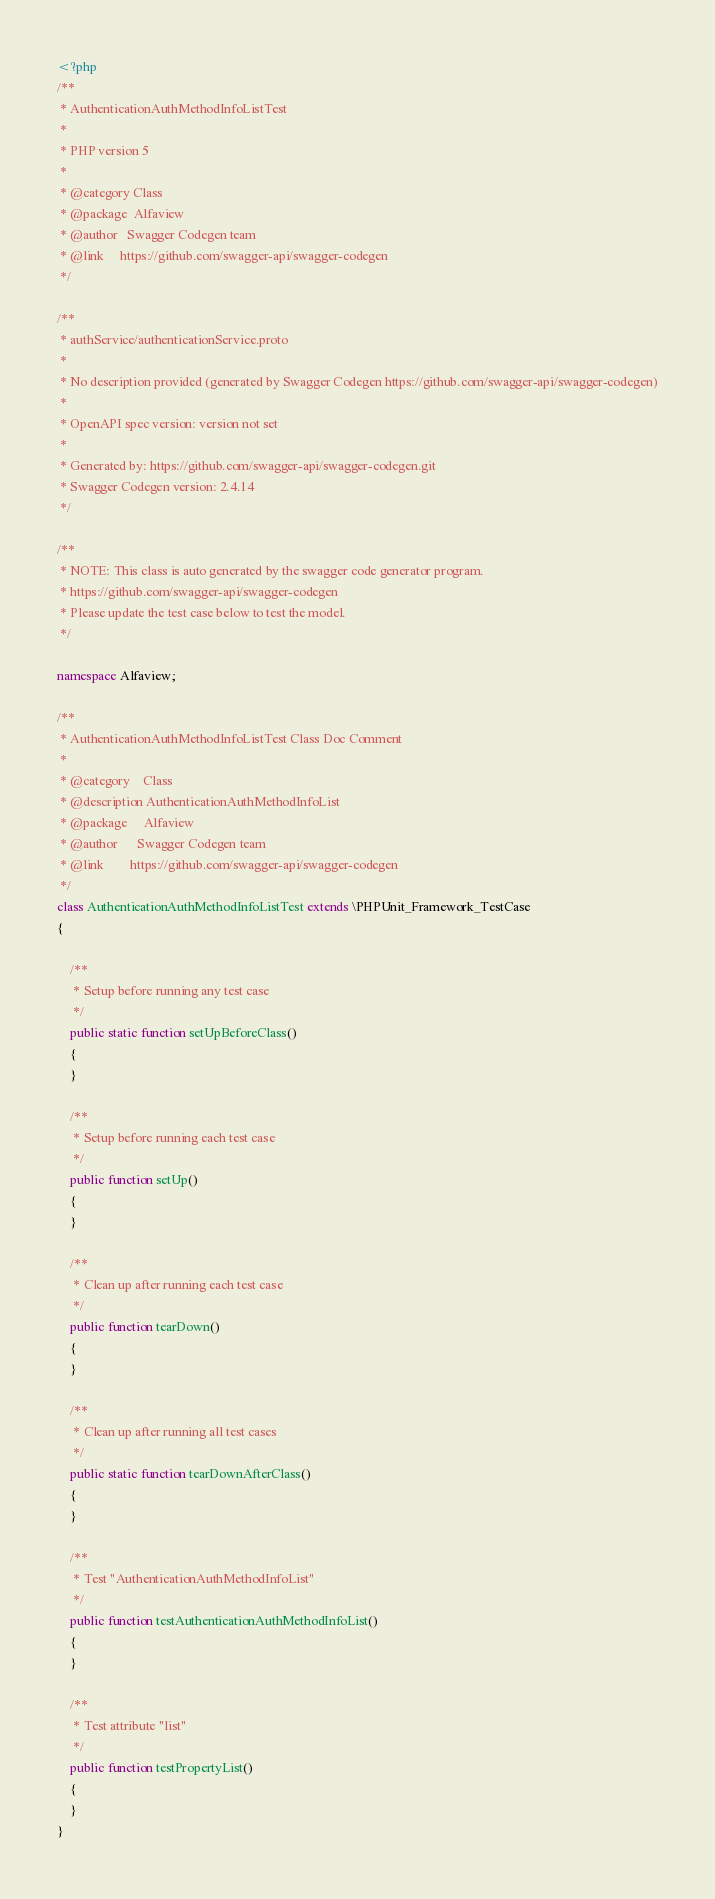Convert code to text. <code><loc_0><loc_0><loc_500><loc_500><_PHP_><?php
/**
 * AuthenticationAuthMethodInfoListTest
 *
 * PHP version 5
 *
 * @category Class
 * @package  Alfaview
 * @author   Swagger Codegen team
 * @link     https://github.com/swagger-api/swagger-codegen
 */

/**
 * authService/authenticationService.proto
 *
 * No description provided (generated by Swagger Codegen https://github.com/swagger-api/swagger-codegen)
 *
 * OpenAPI spec version: version not set
 * 
 * Generated by: https://github.com/swagger-api/swagger-codegen.git
 * Swagger Codegen version: 2.4.14
 */

/**
 * NOTE: This class is auto generated by the swagger code generator program.
 * https://github.com/swagger-api/swagger-codegen
 * Please update the test case below to test the model.
 */

namespace Alfaview;

/**
 * AuthenticationAuthMethodInfoListTest Class Doc Comment
 *
 * @category    Class
 * @description AuthenticationAuthMethodInfoList
 * @package     Alfaview
 * @author      Swagger Codegen team
 * @link        https://github.com/swagger-api/swagger-codegen
 */
class AuthenticationAuthMethodInfoListTest extends \PHPUnit_Framework_TestCase
{

    /**
     * Setup before running any test case
     */
    public static function setUpBeforeClass()
    {
    }

    /**
     * Setup before running each test case
     */
    public function setUp()
    {
    }

    /**
     * Clean up after running each test case
     */
    public function tearDown()
    {
    }

    /**
     * Clean up after running all test cases
     */
    public static function tearDownAfterClass()
    {
    }

    /**
     * Test "AuthenticationAuthMethodInfoList"
     */
    public function testAuthenticationAuthMethodInfoList()
    {
    }

    /**
     * Test attribute "list"
     */
    public function testPropertyList()
    {
    }
}
</code> 